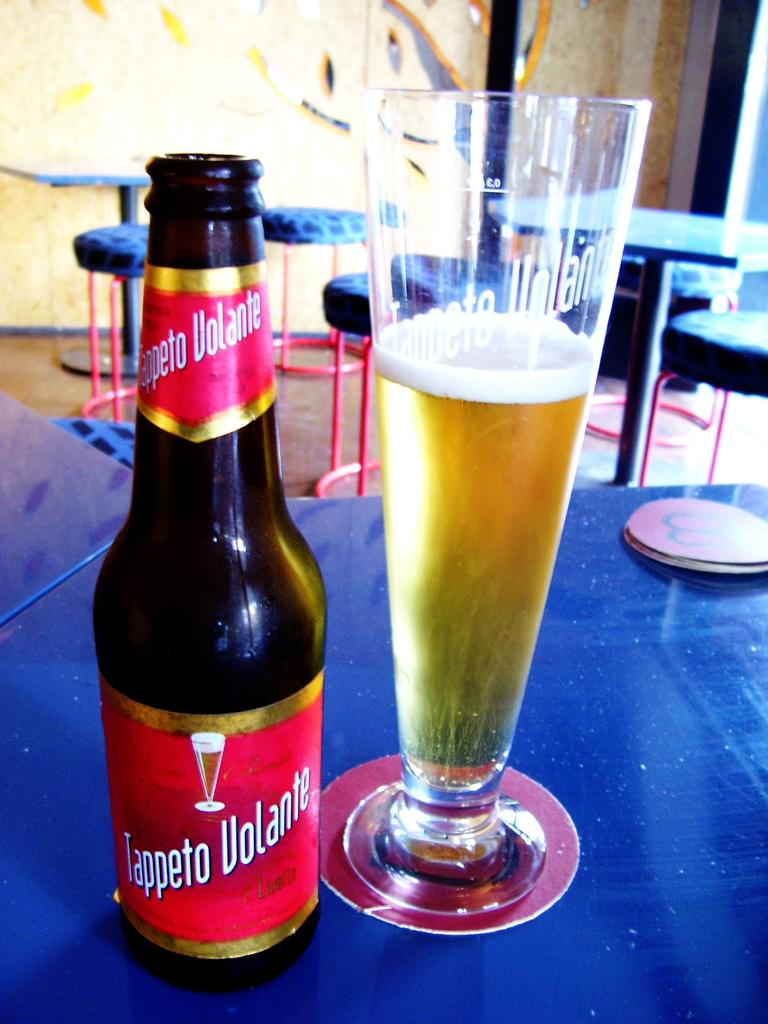<image>
Offer a succinct explanation of the picture presented. A tall glass of beer sits on a table next to a Tappeto Volante bottle. 